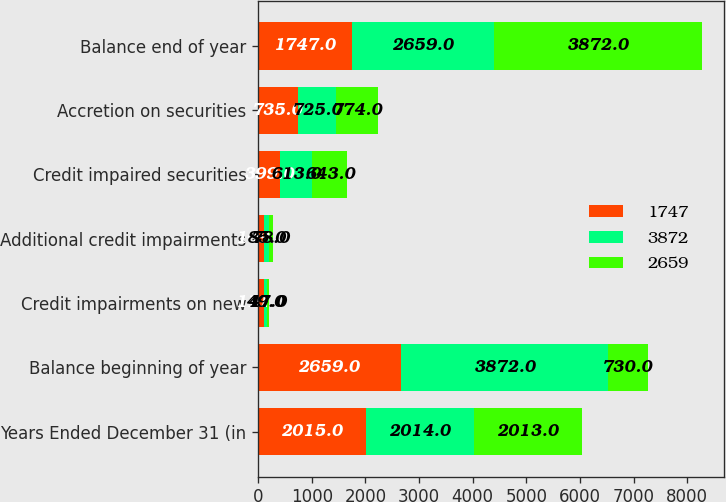Convert chart. <chart><loc_0><loc_0><loc_500><loc_500><stacked_bar_chart><ecel><fcel>Years Ended December 31 (in<fcel>Balance beginning of year<fcel>Credit impairments on new<fcel>Additional credit impairments<fcel>Credit impaired securities<fcel>Accretion on securities<fcel>Balance end of year<nl><fcel>1747<fcel>2015<fcel>2659<fcel>111<fcel>109<fcel>399<fcel>735<fcel>1747<nl><fcel>3872<fcel>2014<fcel>3872<fcel>49<fcel>85<fcel>613<fcel>725<fcel>2659<nl><fcel>2659<fcel>2013<fcel>730<fcel>47<fcel>78<fcel>643<fcel>774<fcel>3872<nl></chart> 